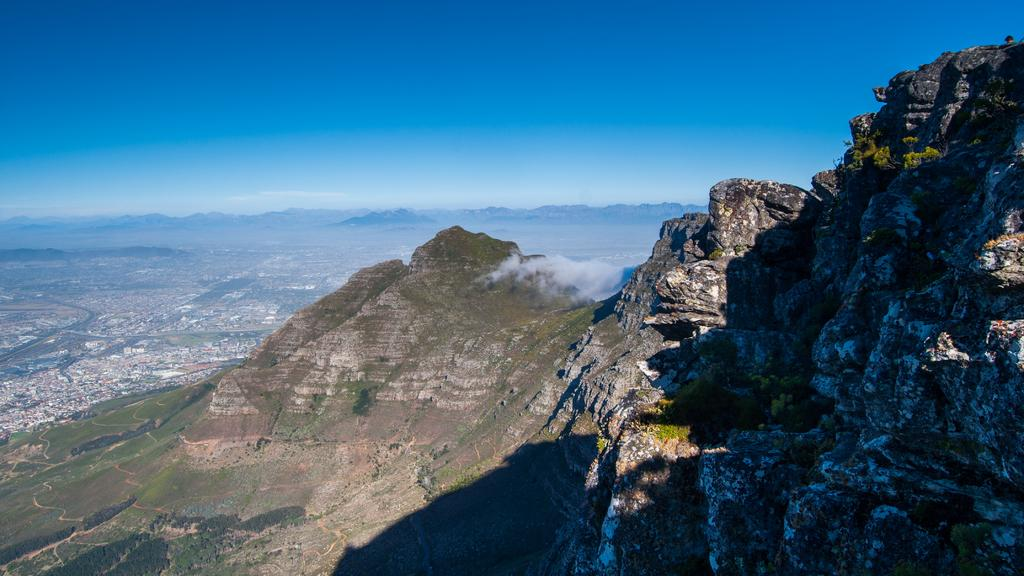What type of natural formation can be seen in the image? There are mountains in the image. What is visible in the air near the mountains? There is smoke visible in the image. What type of vegetation is present in the image? There is grass in the image. Is there a designated route for people or vehicles in the image? Yes, there is a path in the image. What color is the sky in the image? The sky is blue in the image. How much rain is falling during the rainstorm in the image? There is no rainstorm present in the image; it features mountains, smoke, grass, a path, and a blue sky. How many times has the cloth been folded in the image? There is no cloth or folding activity present in the image. 